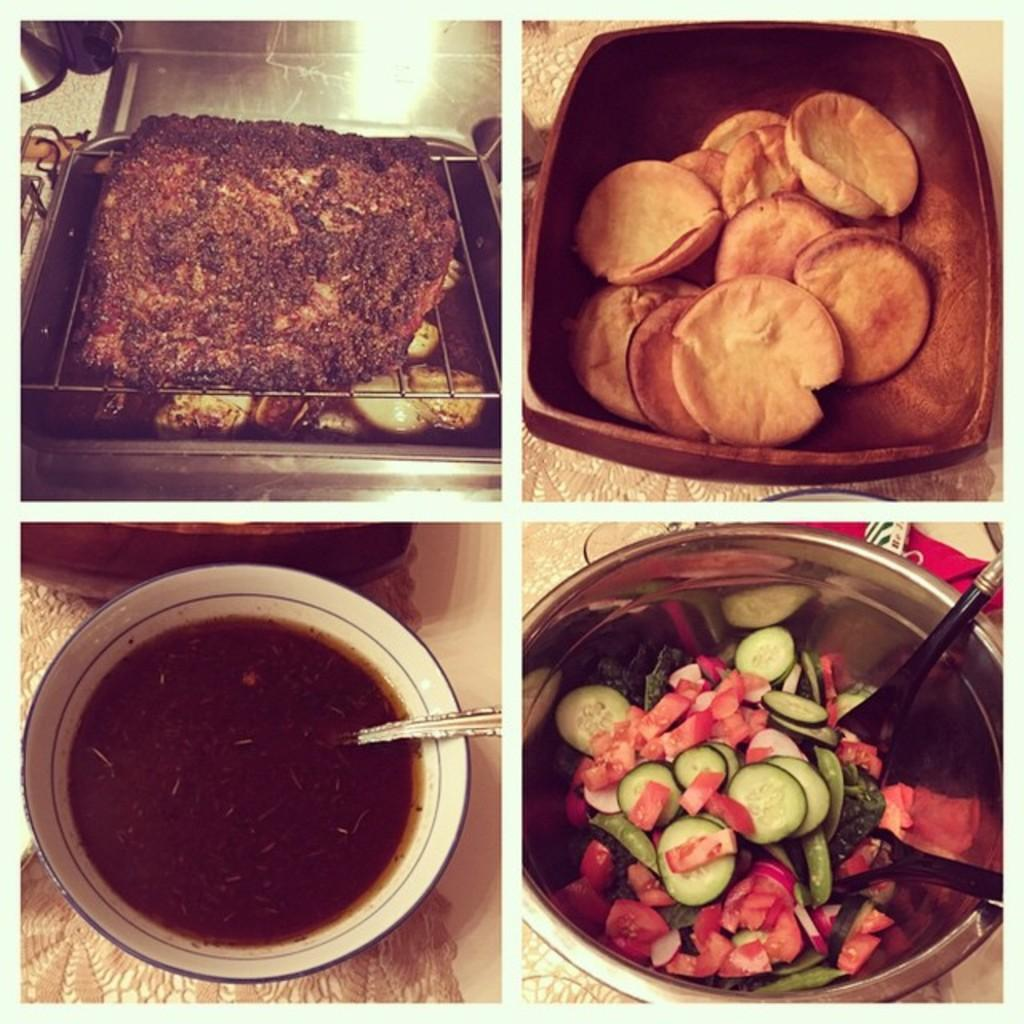What type of artwork is depicted in the image? The image is a collage. What can be found inside the containers in the image? There are food items in the containers in the image. How many dogs are kicking a ball in the image? There are no dogs or balls present in the image; it is a collage featuring food items in containers. 